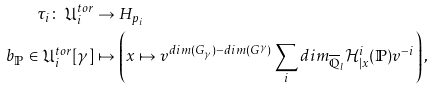<formula> <loc_0><loc_0><loc_500><loc_500>\tau _ { i } \colon \, \mathfrak { U } _ { i } ^ { t o r } & \to H _ { p _ { i } } \\ b _ { \mathbb { P } } \in \mathfrak { U } _ { i } ^ { t o r } [ \gamma ] & \mapsto \left ( x \mapsto v ^ { d i m ( G _ { \gamma } ) - d i m ( G ^ { \gamma } ) } \sum _ { i } d i m _ { \overline { \mathbb { Q } } _ { l } } \mathcal { H } ^ { i } _ { | x } ( \mathbb { P } ) v ^ { - i } \right ) ,</formula> 